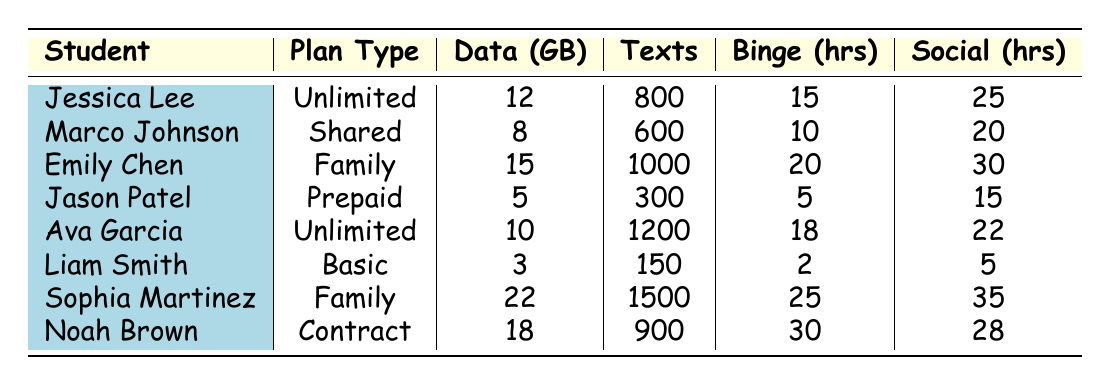What is the highest data usage recorded in the table? The table lists the data usage for each student. The highest data usage is 22 GB, recorded for Sophia Martinez.
Answer: 22 GB Who used the most voice minutes? The table shows voice minutes used by each student. Sophia Martinez used 800 voice minutes, which is the highest compared to others.
Answer: 800 minutes What is the total number of text messages sent by all students? To find the total text messages, we sum the values from each student: 800 + 600 + 1000 + 300 + 1200 + 150 + 1500 + 900 = 4650.
Answer: 4650 messages Which plan type had the least data usage? Liam Smith has the Basic plan with 3 GB of data usage, which is lower than all other plan types listed in the table.
Answer: Basic plan How many hours did Noah Brown spend on social media? According to the table, Noah Brown spent 28 hours on social media, as indicated directly in the relevant row.
Answer: 28 hours What is the average binge-watching hours of all students? To find the average, we sum the binge-watching hours: 15 + 10 + 20 + 5 + 18 + 2 + 25 + 30 = 125, then divide by the number of students (8): 125/8 = 15.625.
Answer: 15.625 hours Is Marco Johnson's data usage greater than Jason Patel's? Marco Johnson's data usage is 8 GB and Jason Patel's is 5 GB. Since 8 is greater than 5, the statement is true.
Answer: Yes Which student used more voice minutes: Ava Garcia or Jason Patel? Ava Garcia used 600 voice minutes while Jason Patel used 100 minutes. Since 600 is greater than 100, Ava Garcia used more voice minutes.
Answer: Ava Garcia What percentage of total binge-watching hours does Sophia Martinez represent? First, we find total binge-watching hours: 15 + 10 + 20 + 5 + 18 + 2 + 25 + 30 = 125. Sophia Martinez's hours are 25. To find the percentage, (25 / 125) * 100 = 20%.
Answer: 20% How many students have 'Family' as their plan type? There are two students: Emily Chen and Sophia Martinez, both of whom have 'Family' listed as their plan type.
Answer: 2 students 